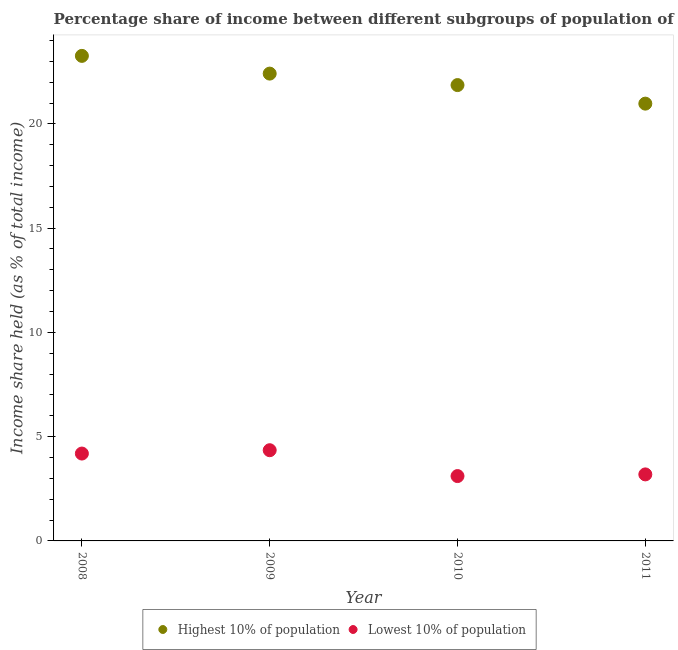How many different coloured dotlines are there?
Make the answer very short. 2. Is the number of dotlines equal to the number of legend labels?
Give a very brief answer. Yes. What is the income share held by lowest 10% of the population in 2011?
Provide a succinct answer. 3.19. Across all years, what is the maximum income share held by highest 10% of the population?
Offer a terse response. 23.26. Across all years, what is the minimum income share held by highest 10% of the population?
Ensure brevity in your answer.  20.97. What is the total income share held by lowest 10% of the population in the graph?
Your response must be concise. 14.84. What is the difference between the income share held by lowest 10% of the population in 2010 and that in 2011?
Your response must be concise. -0.08. What is the difference between the income share held by lowest 10% of the population in 2011 and the income share held by highest 10% of the population in 2010?
Your answer should be compact. -18.67. What is the average income share held by highest 10% of the population per year?
Your answer should be very brief. 22.12. In the year 2010, what is the difference between the income share held by lowest 10% of the population and income share held by highest 10% of the population?
Make the answer very short. -18.75. In how many years, is the income share held by highest 10% of the population greater than 17 %?
Provide a succinct answer. 4. What is the ratio of the income share held by highest 10% of the population in 2010 to that in 2011?
Your answer should be very brief. 1.04. Is the difference between the income share held by highest 10% of the population in 2008 and 2009 greater than the difference between the income share held by lowest 10% of the population in 2008 and 2009?
Ensure brevity in your answer.  Yes. What is the difference between the highest and the second highest income share held by lowest 10% of the population?
Offer a terse response. 0.16. What is the difference between the highest and the lowest income share held by lowest 10% of the population?
Your response must be concise. 1.24. Is the sum of the income share held by lowest 10% of the population in 2008 and 2009 greater than the maximum income share held by highest 10% of the population across all years?
Keep it short and to the point. No. Is the income share held by lowest 10% of the population strictly greater than the income share held by highest 10% of the population over the years?
Give a very brief answer. No. What is the difference between two consecutive major ticks on the Y-axis?
Your answer should be very brief. 5. Does the graph contain any zero values?
Your response must be concise. No. How many legend labels are there?
Your response must be concise. 2. What is the title of the graph?
Your answer should be compact. Percentage share of income between different subgroups of population of Slovak Republic. What is the label or title of the Y-axis?
Keep it short and to the point. Income share held (as % of total income). What is the Income share held (as % of total income) of Highest 10% of population in 2008?
Offer a terse response. 23.26. What is the Income share held (as % of total income) in Lowest 10% of population in 2008?
Your answer should be very brief. 4.19. What is the Income share held (as % of total income) in Highest 10% of population in 2009?
Your response must be concise. 22.41. What is the Income share held (as % of total income) in Lowest 10% of population in 2009?
Offer a terse response. 4.35. What is the Income share held (as % of total income) in Highest 10% of population in 2010?
Your answer should be compact. 21.86. What is the Income share held (as % of total income) in Lowest 10% of population in 2010?
Ensure brevity in your answer.  3.11. What is the Income share held (as % of total income) in Highest 10% of population in 2011?
Make the answer very short. 20.97. What is the Income share held (as % of total income) of Lowest 10% of population in 2011?
Offer a very short reply. 3.19. Across all years, what is the maximum Income share held (as % of total income) in Highest 10% of population?
Make the answer very short. 23.26. Across all years, what is the maximum Income share held (as % of total income) in Lowest 10% of population?
Ensure brevity in your answer.  4.35. Across all years, what is the minimum Income share held (as % of total income) in Highest 10% of population?
Your answer should be compact. 20.97. Across all years, what is the minimum Income share held (as % of total income) in Lowest 10% of population?
Ensure brevity in your answer.  3.11. What is the total Income share held (as % of total income) in Highest 10% of population in the graph?
Ensure brevity in your answer.  88.5. What is the total Income share held (as % of total income) of Lowest 10% of population in the graph?
Your response must be concise. 14.84. What is the difference between the Income share held (as % of total income) in Lowest 10% of population in 2008 and that in 2009?
Offer a very short reply. -0.16. What is the difference between the Income share held (as % of total income) in Highest 10% of population in 2008 and that in 2010?
Make the answer very short. 1.4. What is the difference between the Income share held (as % of total income) of Highest 10% of population in 2008 and that in 2011?
Offer a very short reply. 2.29. What is the difference between the Income share held (as % of total income) of Highest 10% of population in 2009 and that in 2010?
Provide a succinct answer. 0.55. What is the difference between the Income share held (as % of total income) in Lowest 10% of population in 2009 and that in 2010?
Give a very brief answer. 1.24. What is the difference between the Income share held (as % of total income) in Highest 10% of population in 2009 and that in 2011?
Your answer should be compact. 1.44. What is the difference between the Income share held (as % of total income) of Lowest 10% of population in 2009 and that in 2011?
Make the answer very short. 1.16. What is the difference between the Income share held (as % of total income) of Highest 10% of population in 2010 and that in 2011?
Offer a terse response. 0.89. What is the difference between the Income share held (as % of total income) in Lowest 10% of population in 2010 and that in 2011?
Provide a short and direct response. -0.08. What is the difference between the Income share held (as % of total income) of Highest 10% of population in 2008 and the Income share held (as % of total income) of Lowest 10% of population in 2009?
Ensure brevity in your answer.  18.91. What is the difference between the Income share held (as % of total income) of Highest 10% of population in 2008 and the Income share held (as % of total income) of Lowest 10% of population in 2010?
Provide a succinct answer. 20.15. What is the difference between the Income share held (as % of total income) in Highest 10% of population in 2008 and the Income share held (as % of total income) in Lowest 10% of population in 2011?
Provide a succinct answer. 20.07. What is the difference between the Income share held (as % of total income) of Highest 10% of population in 2009 and the Income share held (as % of total income) of Lowest 10% of population in 2010?
Your response must be concise. 19.3. What is the difference between the Income share held (as % of total income) of Highest 10% of population in 2009 and the Income share held (as % of total income) of Lowest 10% of population in 2011?
Your answer should be very brief. 19.22. What is the difference between the Income share held (as % of total income) of Highest 10% of population in 2010 and the Income share held (as % of total income) of Lowest 10% of population in 2011?
Your response must be concise. 18.67. What is the average Income share held (as % of total income) in Highest 10% of population per year?
Your answer should be very brief. 22.12. What is the average Income share held (as % of total income) in Lowest 10% of population per year?
Your answer should be compact. 3.71. In the year 2008, what is the difference between the Income share held (as % of total income) of Highest 10% of population and Income share held (as % of total income) of Lowest 10% of population?
Your answer should be compact. 19.07. In the year 2009, what is the difference between the Income share held (as % of total income) in Highest 10% of population and Income share held (as % of total income) in Lowest 10% of population?
Keep it short and to the point. 18.06. In the year 2010, what is the difference between the Income share held (as % of total income) in Highest 10% of population and Income share held (as % of total income) in Lowest 10% of population?
Offer a terse response. 18.75. In the year 2011, what is the difference between the Income share held (as % of total income) in Highest 10% of population and Income share held (as % of total income) in Lowest 10% of population?
Ensure brevity in your answer.  17.78. What is the ratio of the Income share held (as % of total income) of Highest 10% of population in 2008 to that in 2009?
Keep it short and to the point. 1.04. What is the ratio of the Income share held (as % of total income) of Lowest 10% of population in 2008 to that in 2009?
Keep it short and to the point. 0.96. What is the ratio of the Income share held (as % of total income) of Highest 10% of population in 2008 to that in 2010?
Ensure brevity in your answer.  1.06. What is the ratio of the Income share held (as % of total income) in Lowest 10% of population in 2008 to that in 2010?
Give a very brief answer. 1.35. What is the ratio of the Income share held (as % of total income) of Highest 10% of population in 2008 to that in 2011?
Keep it short and to the point. 1.11. What is the ratio of the Income share held (as % of total income) in Lowest 10% of population in 2008 to that in 2011?
Offer a very short reply. 1.31. What is the ratio of the Income share held (as % of total income) in Highest 10% of population in 2009 to that in 2010?
Provide a succinct answer. 1.03. What is the ratio of the Income share held (as % of total income) in Lowest 10% of population in 2009 to that in 2010?
Your answer should be very brief. 1.4. What is the ratio of the Income share held (as % of total income) of Highest 10% of population in 2009 to that in 2011?
Your answer should be very brief. 1.07. What is the ratio of the Income share held (as % of total income) of Lowest 10% of population in 2009 to that in 2011?
Provide a succinct answer. 1.36. What is the ratio of the Income share held (as % of total income) in Highest 10% of population in 2010 to that in 2011?
Offer a very short reply. 1.04. What is the ratio of the Income share held (as % of total income) in Lowest 10% of population in 2010 to that in 2011?
Make the answer very short. 0.97. What is the difference between the highest and the second highest Income share held (as % of total income) in Lowest 10% of population?
Keep it short and to the point. 0.16. What is the difference between the highest and the lowest Income share held (as % of total income) of Highest 10% of population?
Offer a terse response. 2.29. What is the difference between the highest and the lowest Income share held (as % of total income) in Lowest 10% of population?
Provide a short and direct response. 1.24. 